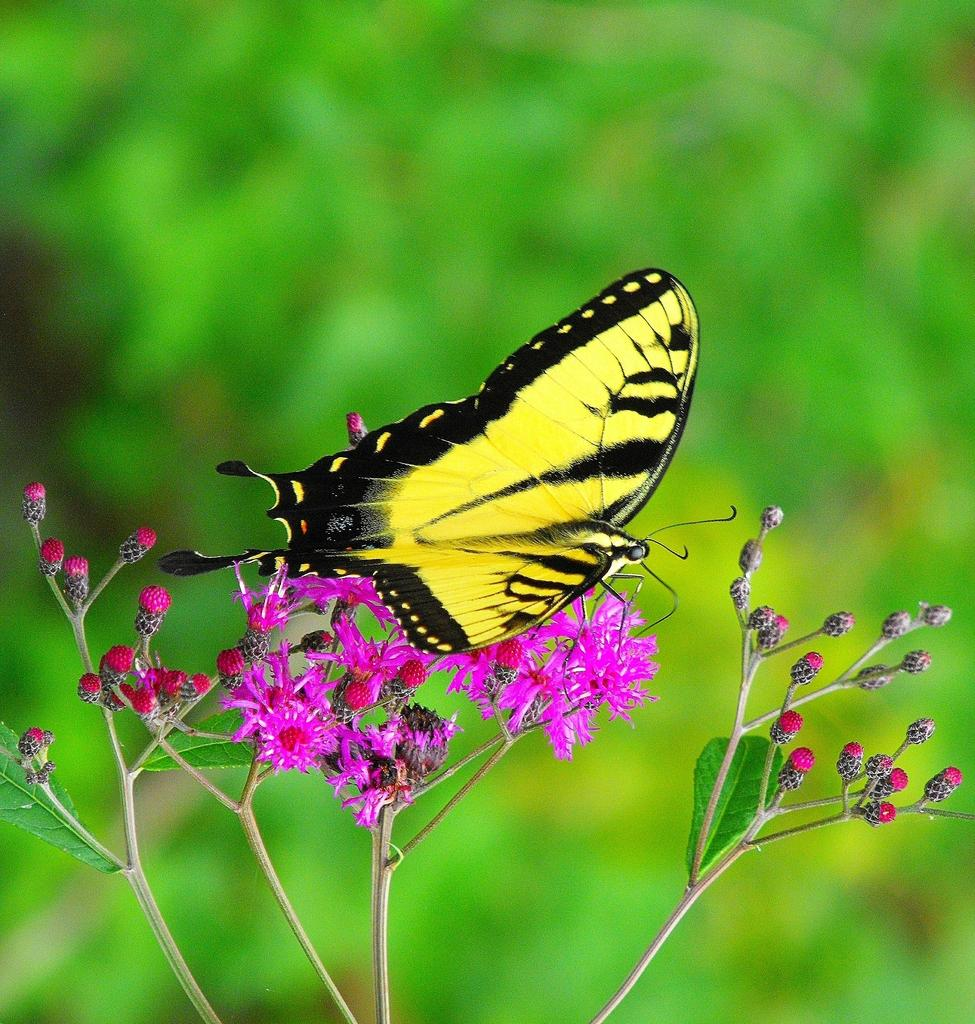What type of insect is in the image? There is a yellow butterfly in the image. What is the butterfly resting on? The butterfly is on a rose-colored flower. What can be seen in the image besides the butterfly and flower? There is a plant in the image, which has leaves and buds. How would you describe the background of the image? The background of the image is blurry. What type of hose is being used in the competition in the image? There is no hose or competition present in the image; it features a yellow butterfly on a rose-colored flower and a plant with leaves and buds. 